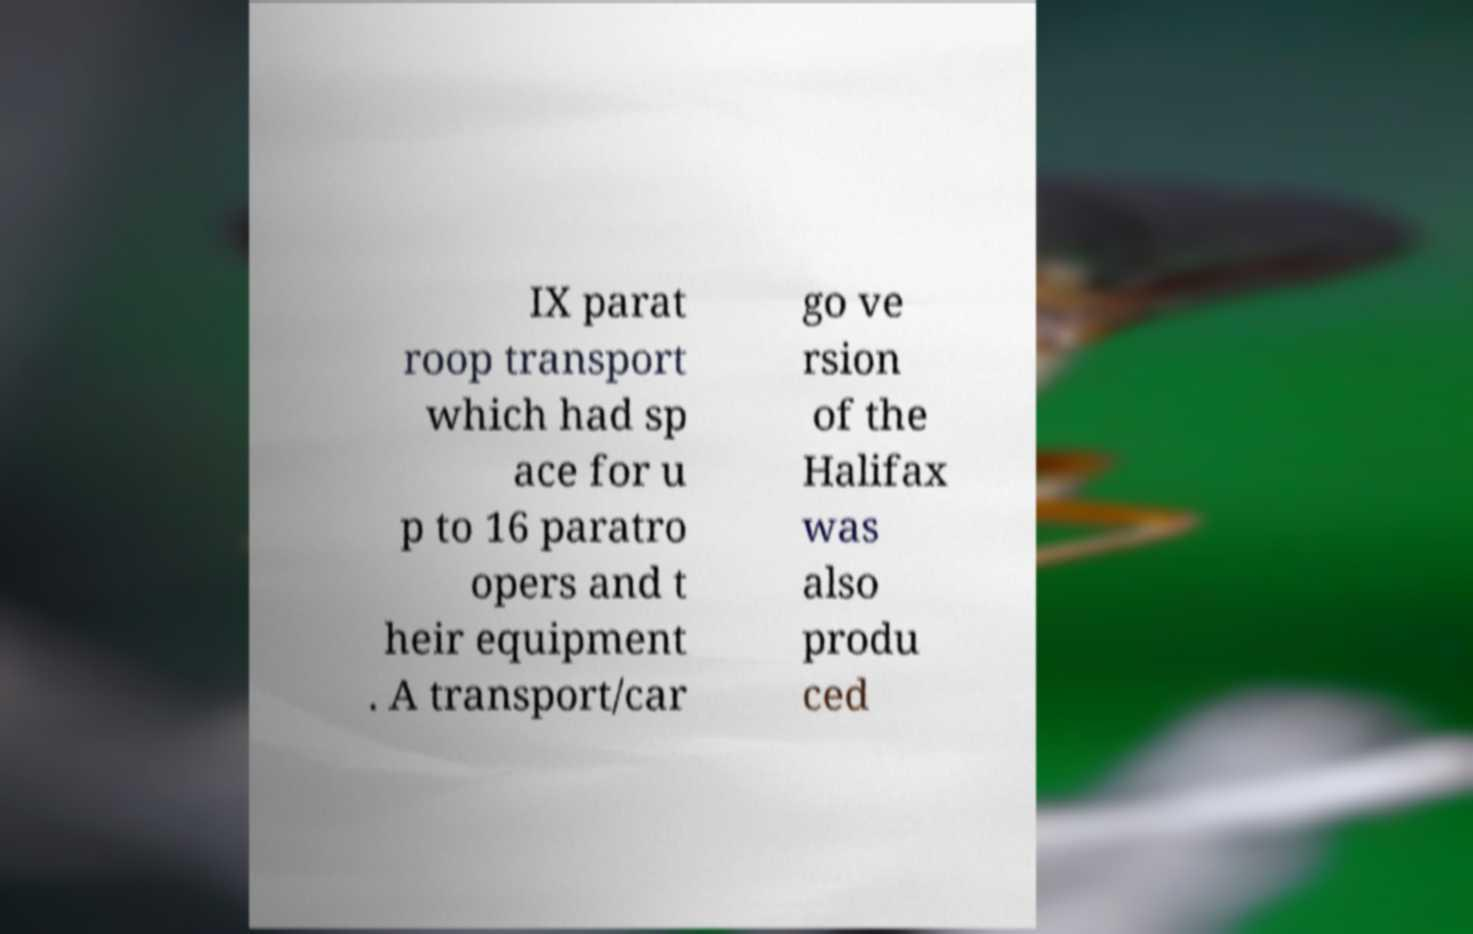I need the written content from this picture converted into text. Can you do that? IX parat roop transport which had sp ace for u p to 16 paratro opers and t heir equipment . A transport/car go ve rsion of the Halifax was also produ ced 